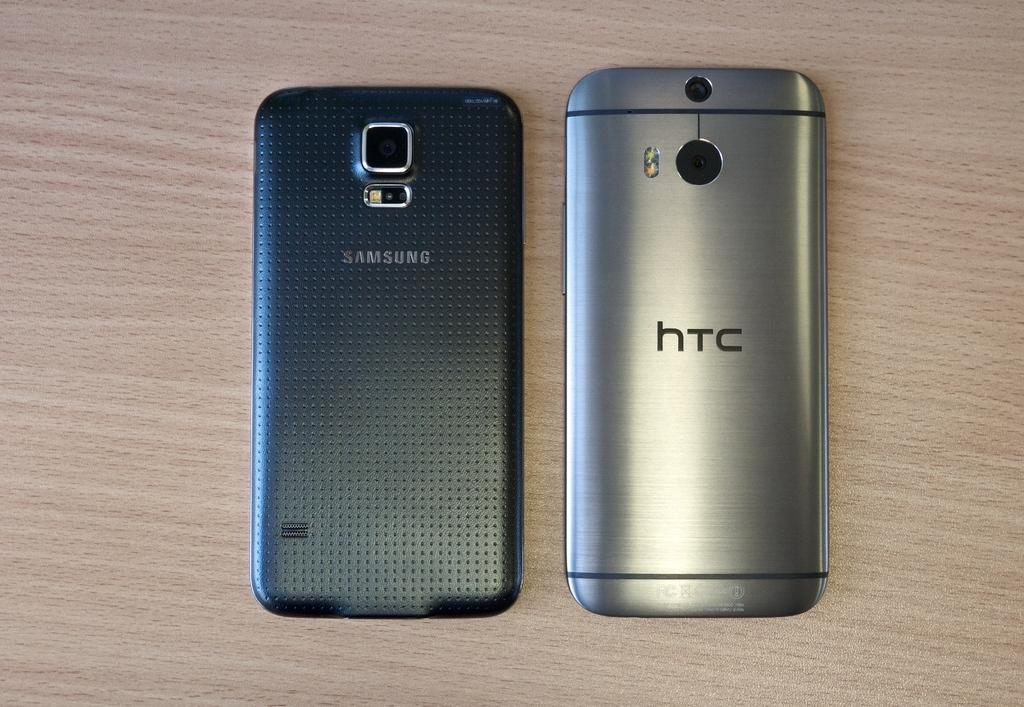<image>
Relay a brief, clear account of the picture shown. two models of phones, one is a SAMSUNG and other is a hTC. 